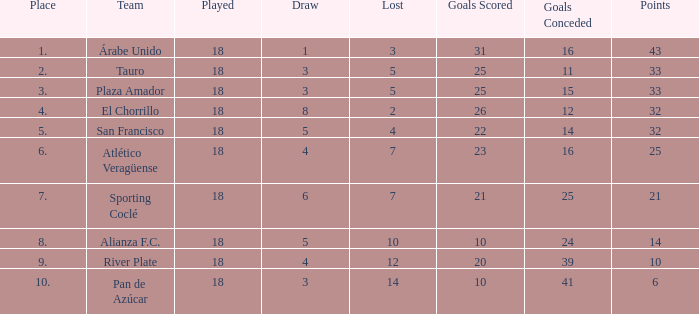What was the team's total points when they allowed 41 goals and finished in a position higher than 10th place? 0.0. 